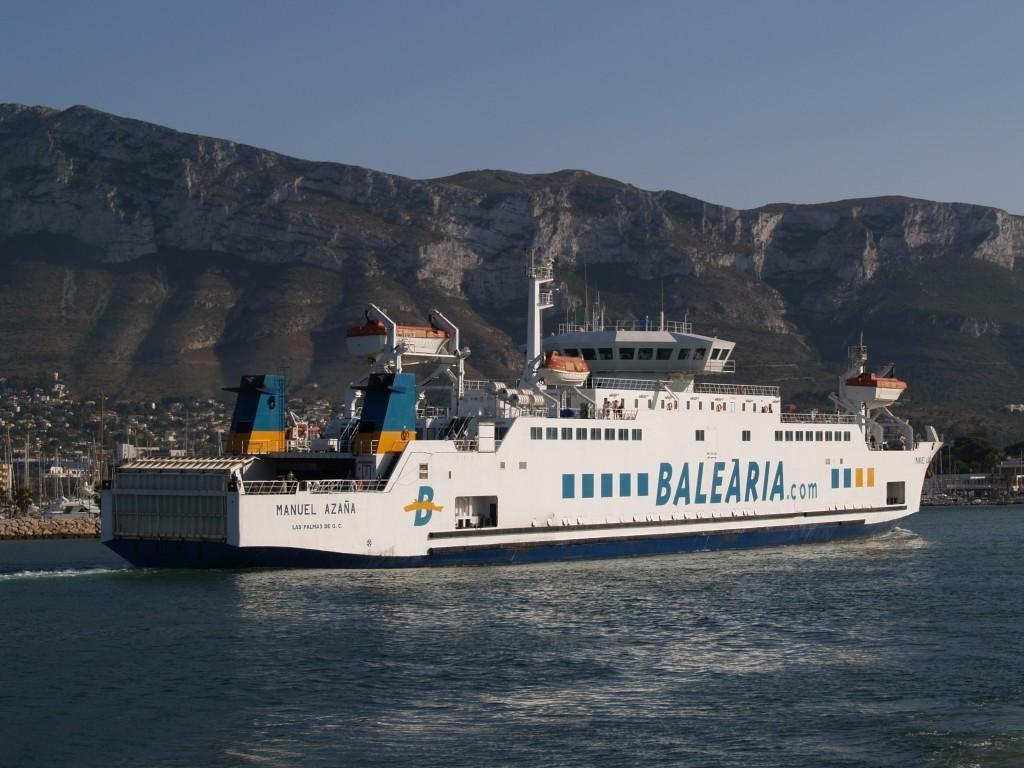Please provide a concise description of this image. In this image there is a ship in the water. At the background there are buildings, mountains and sky. 